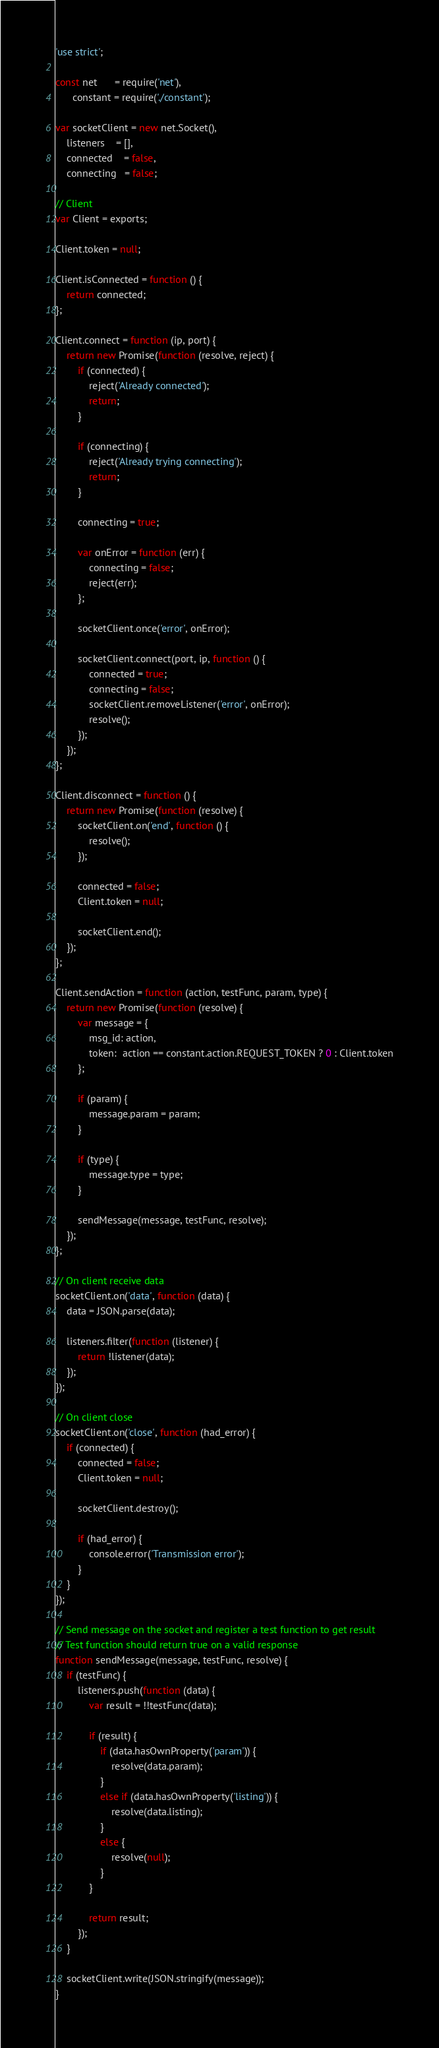Convert code to text. <code><loc_0><loc_0><loc_500><loc_500><_JavaScript_>'use strict';

const net      = require('net'),
      constant = require('./constant');

var socketClient = new net.Socket(),
    listeners    = [],
    connected    = false,
    connecting   = false;

// Client
var Client = exports;

Client.token = null;

Client.isConnected = function () {
    return connected;
};

Client.connect = function (ip, port) {
    return new Promise(function (resolve, reject) {
        if (connected) {
            reject('Already connected');
            return;
        }

        if (connecting) {
            reject('Already trying connecting');
            return;
        }

        connecting = true;

        var onError = function (err) {
            connecting = false;
            reject(err);
        };

        socketClient.once('error', onError);

        socketClient.connect(port, ip, function () {
            connected = true;
            connecting = false;
            socketClient.removeListener('error', onError);
            resolve();
        });
    });
};

Client.disconnect = function () {
    return new Promise(function (resolve) {
        socketClient.on('end', function () {
            resolve();
        });

        connected = false;
        Client.token = null;

        socketClient.end();
    });
};

Client.sendAction = function (action, testFunc, param, type) {
    return new Promise(function (resolve) {
        var message = {
            msg_id: action,
            token:  action == constant.action.REQUEST_TOKEN ? 0 : Client.token
        };

        if (param) {
            message.param = param;
        }

        if (type) {
            message.type = type;
        }

        sendMessage(message, testFunc, resolve);
    });
};

// On client receive data
socketClient.on('data', function (data) {
    data = JSON.parse(data);

    listeners.filter(function (listener) {
        return !listener(data);
    });
});

// On client close
socketClient.on('close', function (had_error) {
    if (connected) {
        connected = false;
        Client.token = null;

        socketClient.destroy();

        if (had_error) {
            console.error('Transmission error');
        }
    }
});

// Send message on the socket and register a test function to get result
// Test function should return true on a valid response
function sendMessage(message, testFunc, resolve) {
    if (testFunc) {
        listeners.push(function (data) {
            var result = !!testFunc(data);

            if (result) {
                if (data.hasOwnProperty('param')) {
                    resolve(data.param);
                }
                else if (data.hasOwnProperty('listing')) {
                    resolve(data.listing);
                }
                else {
                    resolve(null);
                }
            }

            return result;
        });
    }

    socketClient.write(JSON.stringify(message));
}
</code> 